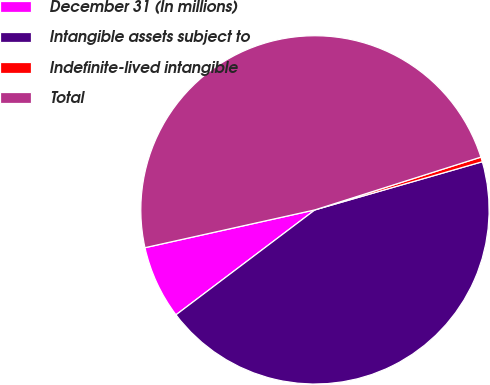<chart> <loc_0><loc_0><loc_500><loc_500><pie_chart><fcel>December 31 (In millions)<fcel>Intangible assets subject to<fcel>Indefinite-lived intangible<fcel>Total<nl><fcel>6.81%<fcel>44.16%<fcel>0.44%<fcel>48.58%<nl></chart> 